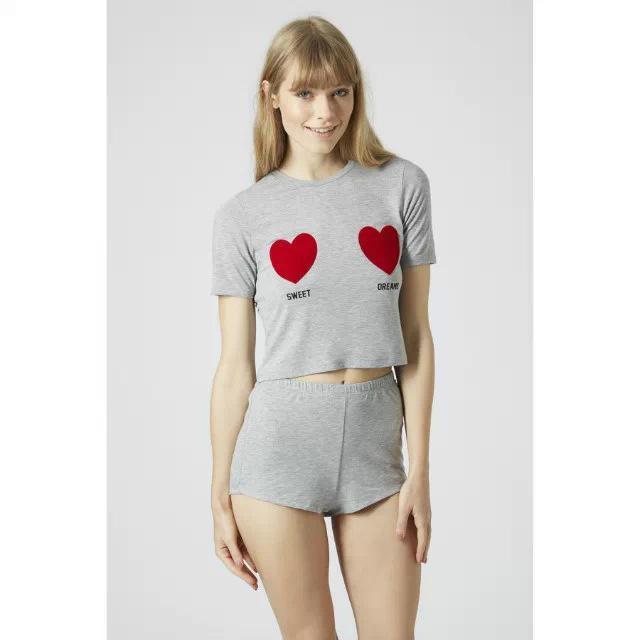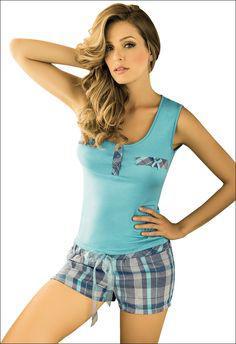The first image is the image on the left, the second image is the image on the right. Assess this claim about the two images: "Left and right images feature models wearing same style outfits.". Correct or not? Answer yes or no. No. 